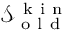<formula> <loc_0><loc_0><loc_500><loc_500>\mathcal { S } _ { o l d } ^ { k i n }</formula> 